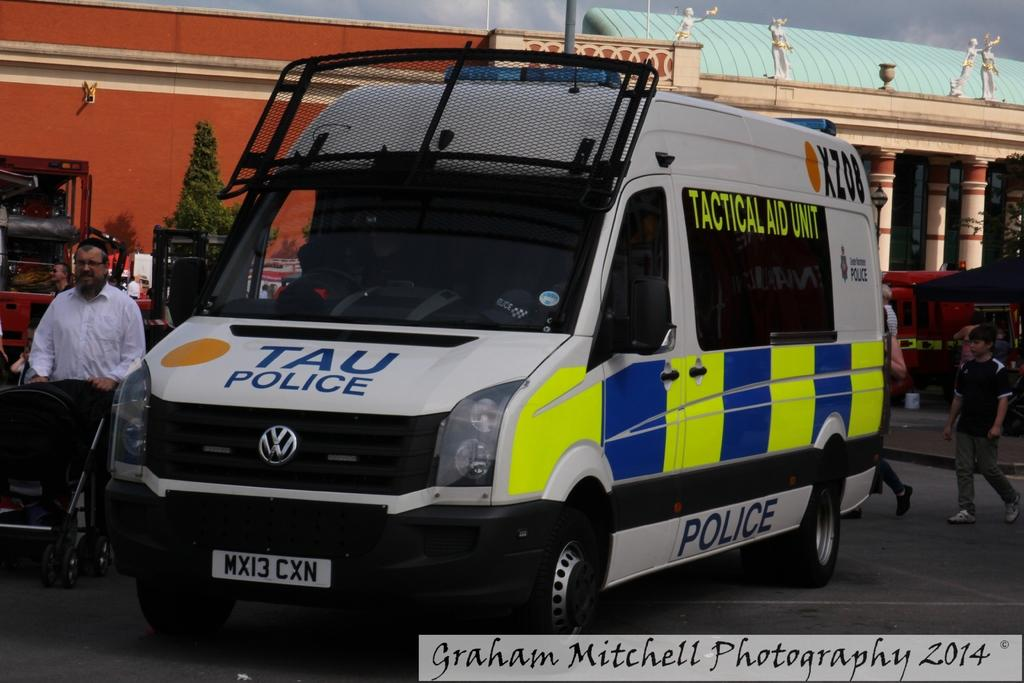<image>
Relay a brief, clear account of the picture shown. A TAU Police vehicle parked in a parking lot taken by Graham Mitchell Photography 2014 